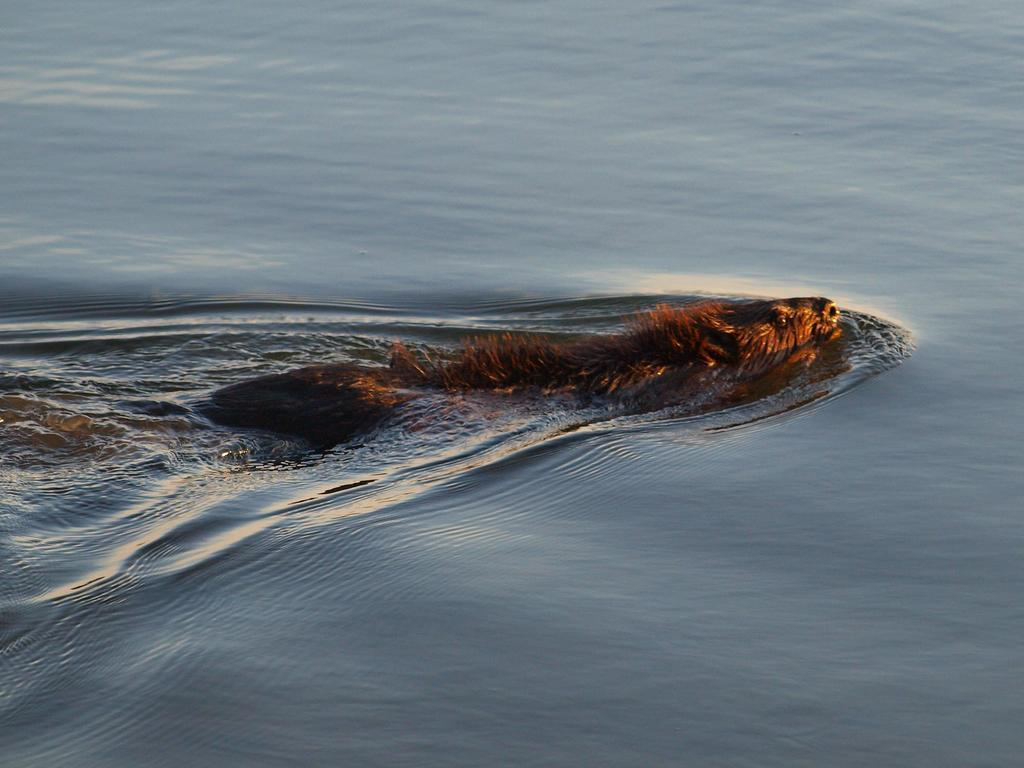What type of animal is in the image? The image contains an animal, but the specific type is not mentioned in the facts. What is the animal doing in the image? The animal is swimming in the water. What is the aftermath of the boys' idea in the image? There is no mention of boys or their ideas in the image, so it is not possible to determine the aftermath of any such scenario. 